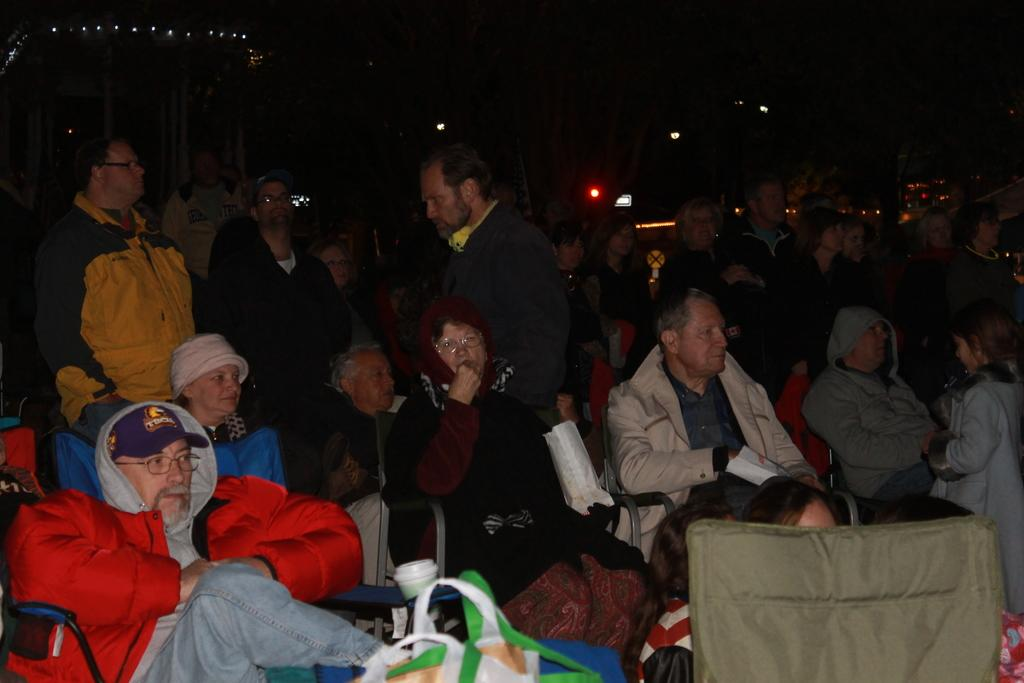What are the people in the image doing? There are people sitting on chairs and standing in the image. What objects can be seen at the bottom of the image? There are bags at the bottom of the image. What can be observed in the background of the image? There are many lights in the background of the image, and the background is dark. What is the title of the book being read by the people in the image? There is no book or reading activity depicted in the image. How much debt do the people in the image owe to the bank? There is no information about debt or finances in the image. 